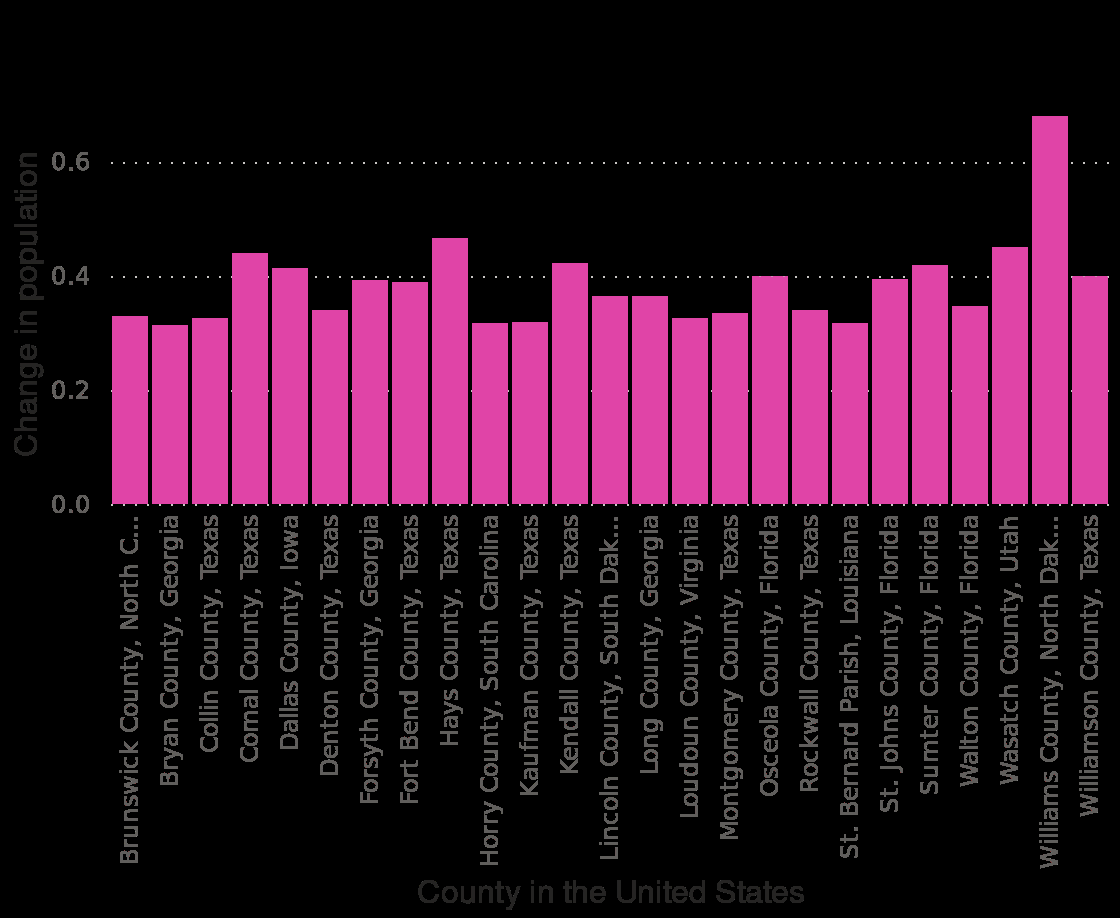<image>
What is the x-axis labeled as in the bar plot? The x-axis in the bar plot is labeled as County in the United States. 